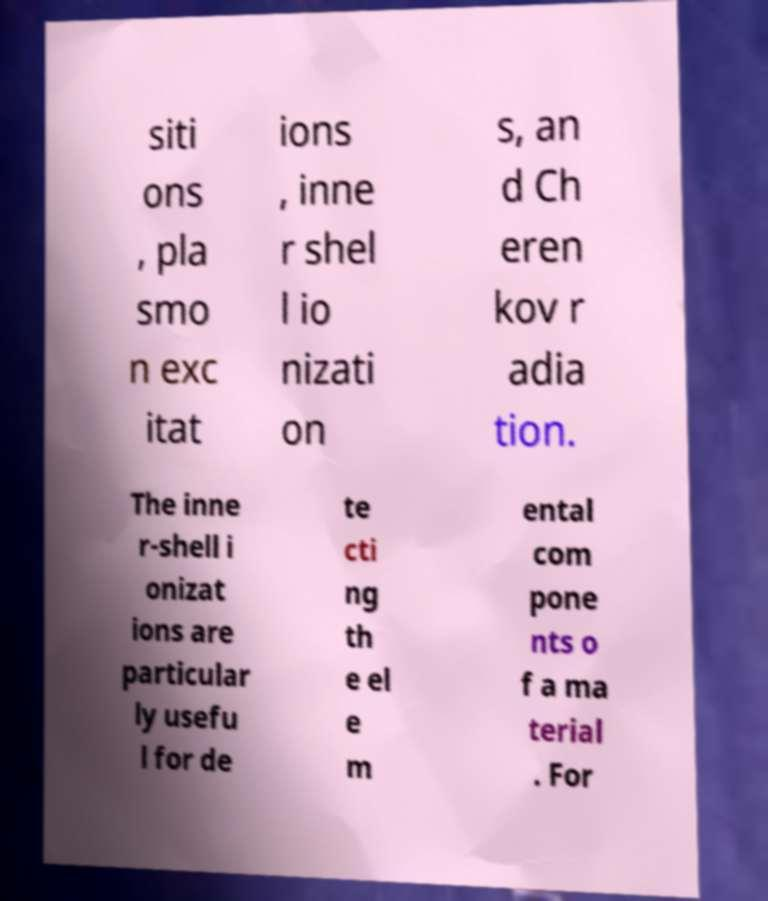What messages or text are displayed in this image? I need them in a readable, typed format. siti ons , pla smo n exc itat ions , inne r shel l io nizati on s, an d Ch eren kov r adia tion. The inne r-shell i onizat ions are particular ly usefu l for de te cti ng th e el e m ental com pone nts o f a ma terial . For 